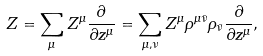Convert formula to latex. <formula><loc_0><loc_0><loc_500><loc_500>Z = \sum _ { \mu } Z ^ { \mu } { \frac { \partial \, } { \partial z ^ { \mu } } } = \sum _ { \mu , \nu } Z ^ { \mu } \rho ^ { \mu \bar { \nu } } \rho _ { \bar { \nu } } \frac { \partial } { \partial z ^ { \mu } } ,</formula> 